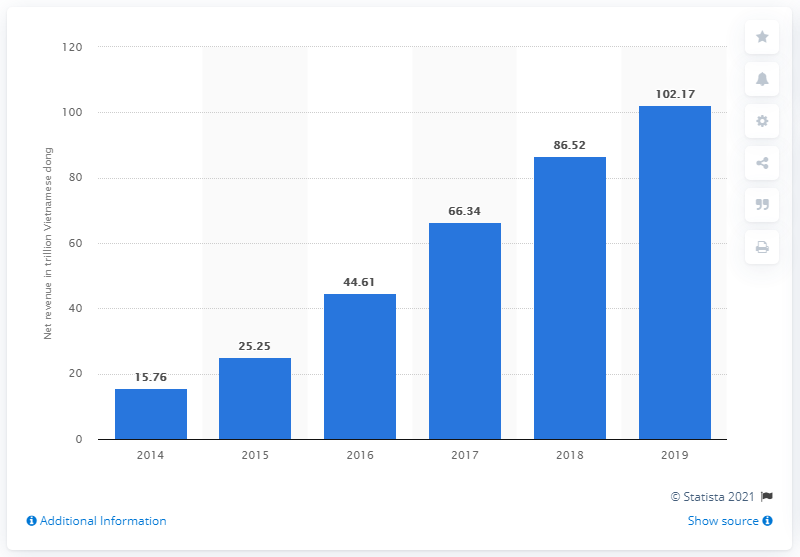Outline some significant characteristics in this image. MWG recorded net revenue of 102.17 in 2019. 